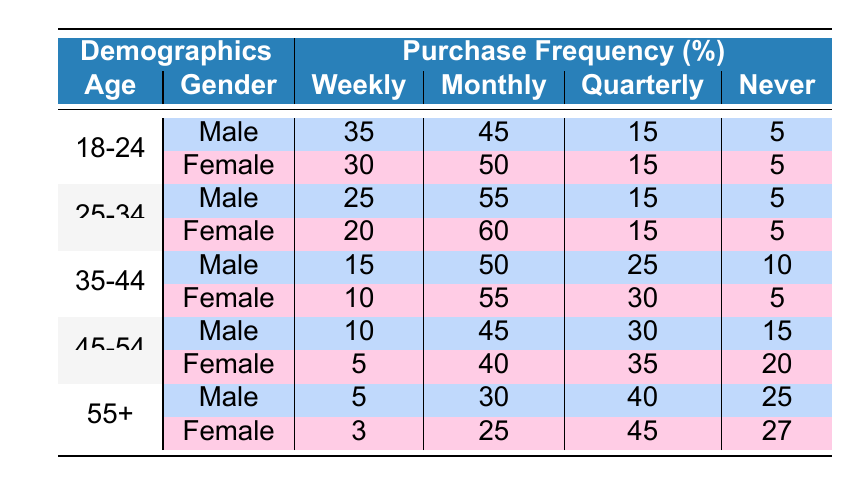What percentage of females aged 18-24 make online purchases weekly? Referring to the table, females aged 18-24 have a weekly purchase frequency of 30%.
Answer: 30% What is the total percentage of males aged 35-44 who either purchase weekly or monthly online? For males aged 35-44, the weekly purchase frequency is 15% and the monthly frequency is 50%. Adding these gives us 15 + 50 = 65%.
Answer: 65% Do more females aged 25-34 purchase online monthly than males of the same age group? The monthly purchase frequency for females aged 25-34 is 60%, while for males it is 55%. Thus, females do purchase more monthly than males in this age group.
Answer: Yes What is the difference in percentage between males and females aged 45-54 who never shop online? Males aged 45-54 who never shop online have a frequency of 15%, whereas females have 20%. The difference is 20 - 15 = 5%.
Answer: 5% What is the average percentage of online purchases made monthly by people aged 55 and older? The monthly frequencies for males and females aged 55+ are 30% and 25%, respectively. The average is (30 + 25) / 2 = 27.5%.
Answer: 27.5% How many age groups have a higher percentage of weekly online purchases among females than males? Analyzing the table, females aged 18-24 and 25-34 have higher weekly purchase frequencies (30% vs 35% and 20% vs 25%, respectively). Thus, there are two age groups.
Answer: 2 